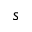<formula> <loc_0><loc_0><loc_500><loc_500>s</formula> 